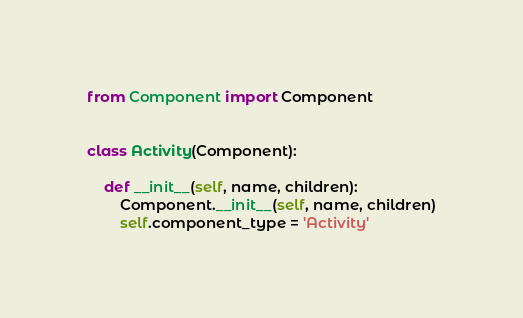Convert code to text. <code><loc_0><loc_0><loc_500><loc_500><_Python_>from Component import Component


class Activity(Component):

    def __init__(self, name, children):
        Component.__init__(self, name, children)
        self.component_type = 'Activity'
</code> 